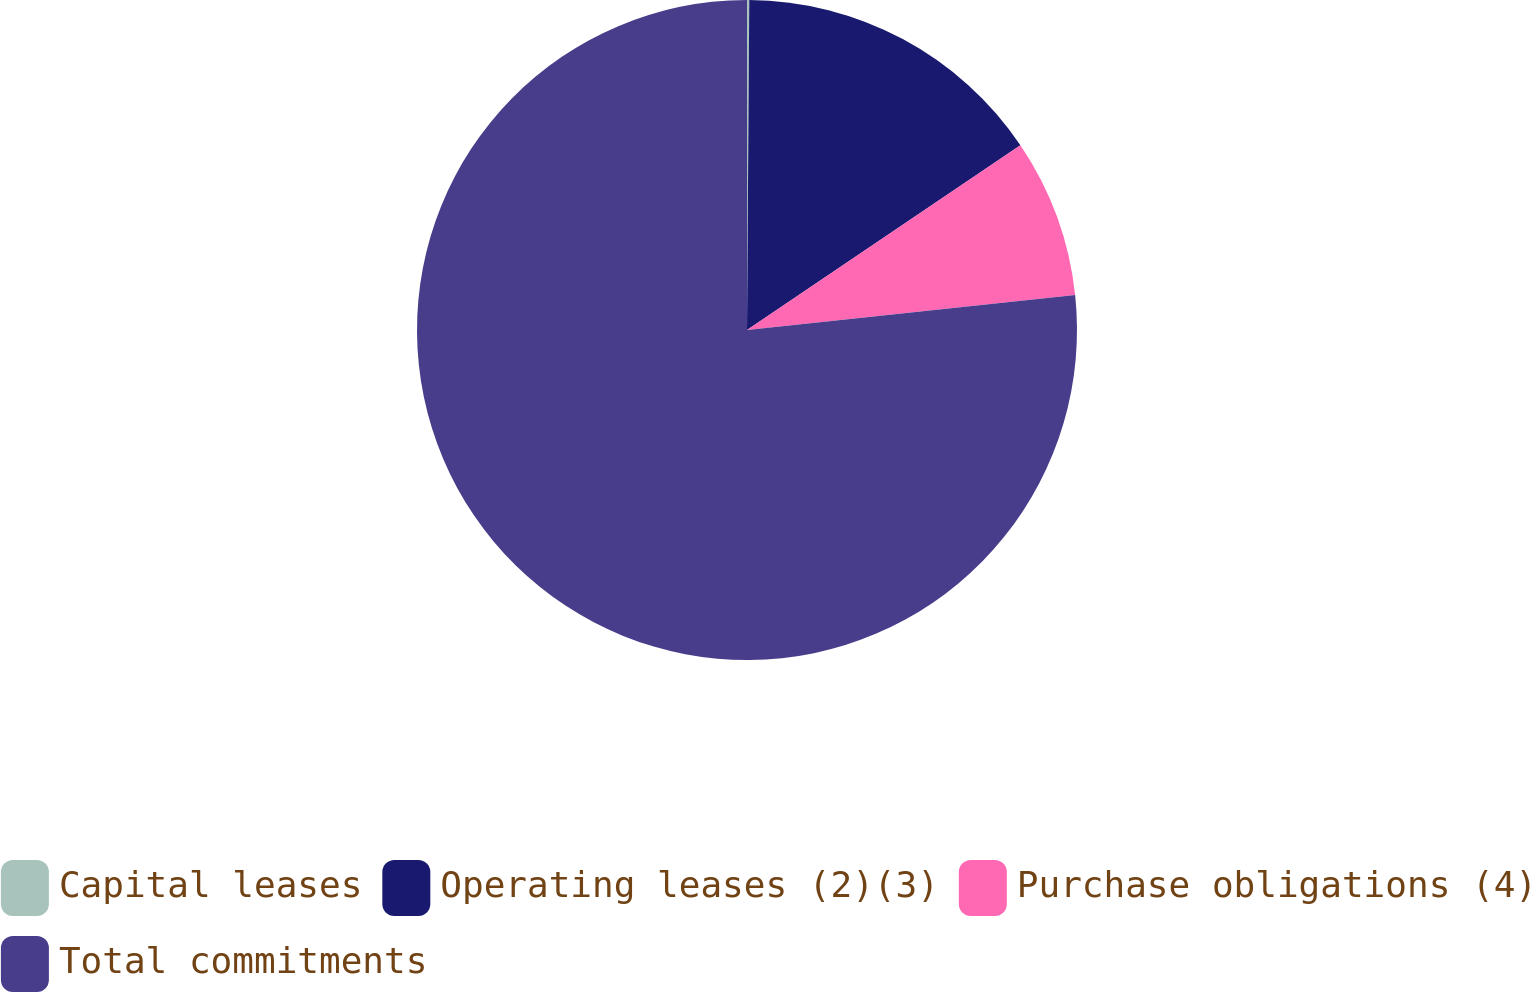Convert chart. <chart><loc_0><loc_0><loc_500><loc_500><pie_chart><fcel>Capital leases<fcel>Operating leases (2)(3)<fcel>Purchase obligations (4)<fcel>Total commitments<nl><fcel>0.11%<fcel>15.43%<fcel>7.77%<fcel>76.69%<nl></chart> 